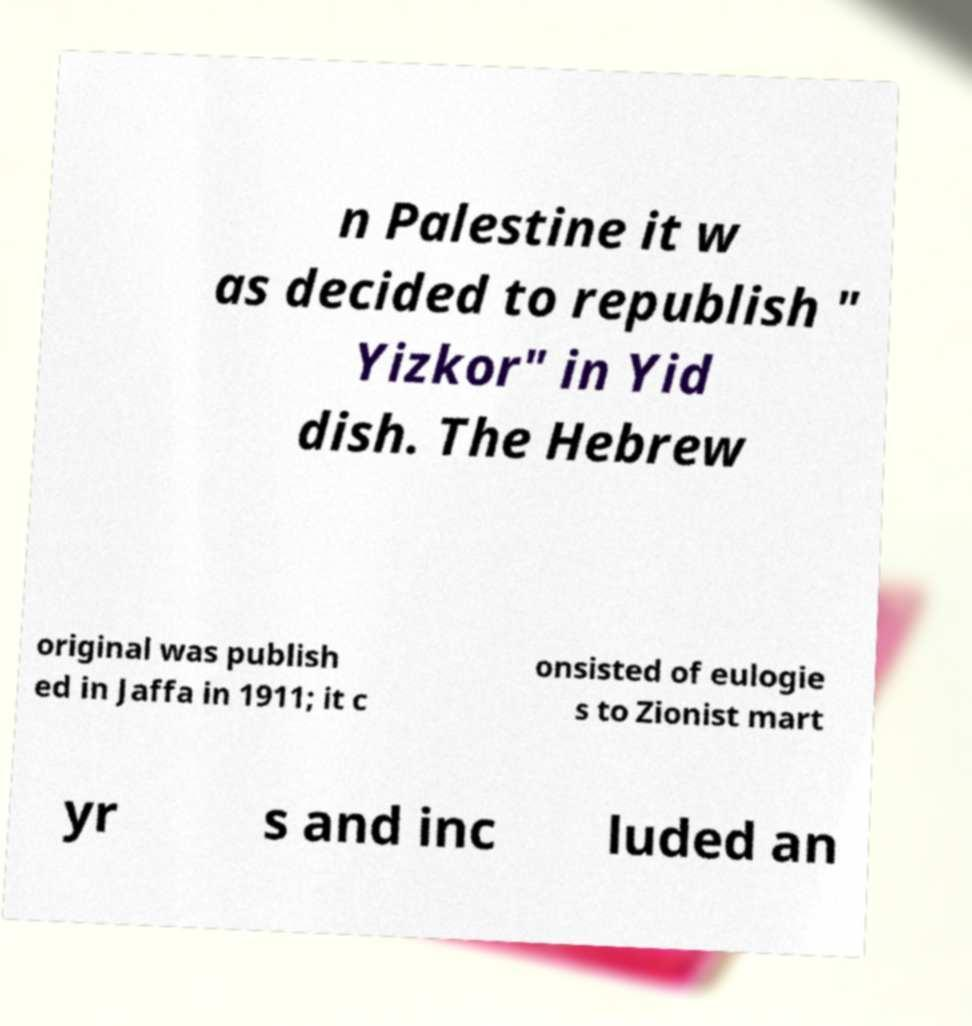For documentation purposes, I need the text within this image transcribed. Could you provide that? n Palestine it w as decided to republish " Yizkor" in Yid dish. The Hebrew original was publish ed in Jaffa in 1911; it c onsisted of eulogie s to Zionist mart yr s and inc luded an 